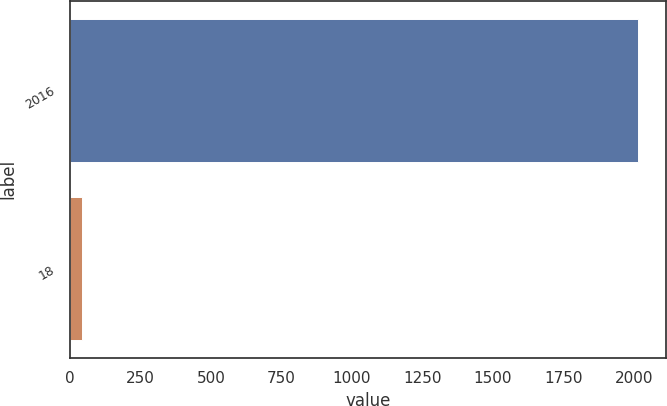<chart> <loc_0><loc_0><loc_500><loc_500><bar_chart><fcel>2016<fcel>18<nl><fcel>2014<fcel>43<nl></chart> 